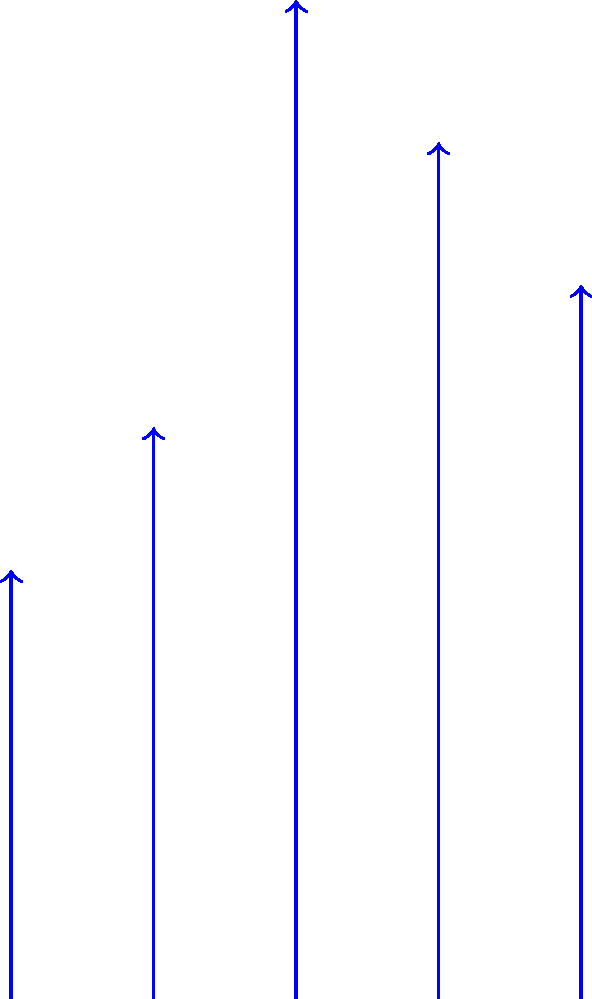The graph shows the stress levels of students from 2018 to 2022, represented by vector arrows of different lengths. Calculate the total change in stress level from 2018 to 2022. If the stress level increased, express your answer as a positive number; if it decreased, express it as a negative number. To find the total change in stress level from 2018 to 2022, we need to:

1. Identify the stress levels for 2018 and 2022:
   - 2018 stress level: 3
   - 2022 stress level: 5

2. Calculate the difference:
   $\text{Change} = \text{Final value} - \text{Initial value}$
   $\text{Change} = 5 - 3 = 2$

3. Interpret the result:
   The change is positive, indicating an increase in stress level from 2018 to 2022.

Therefore, the total change in stress level from 2018 to 2022 is an increase of 2 units.
Answer: 2 